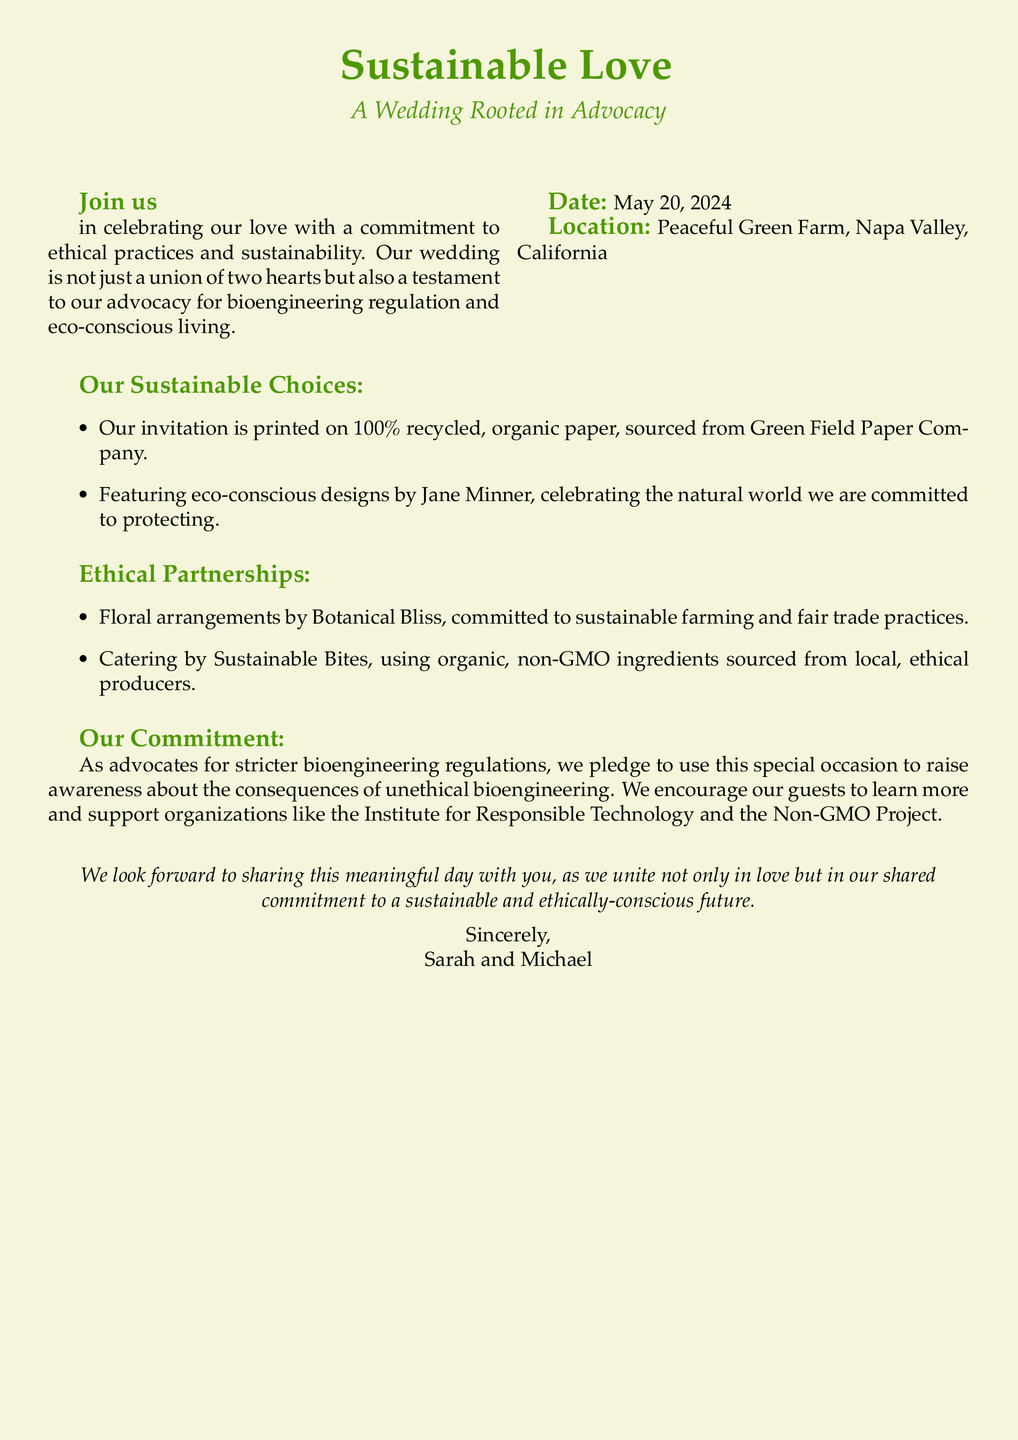What is the title of the wedding celebration? The title is indicated at the top of the document, highlighting the theme of the wedding.
Answer: Sustainable Love What is the wedding date? The document specifies the date of the wedding in a dedicated section.
Answer: May 20, 2024 Where is the wedding location? The location is explicitly mentioned in the invitation details.
Answer: Peaceful Green Farm, Napa Valley, California Who are the couple getting married? The names of the couple are mentioned at the end of the document.
Answer: Sarah and Michael What type of paper is the invitation printed on? The document details the material used for the invitations as a part of their sustainable choices.
Answer: 100% recycled, organic paper Which company designed the eco-conscious invitation? The designer of the invitation is mentioned as part of their sustainable choices in the document.
Answer: Jane Minner What is one of the catering choices mentioned in the document? The document lists the catering service as part of their ethical partnerships.
Answer: Sustainable Bites What do the couple advocate for regarding bioengineering? The document states their commitment and raises awareness about a specific issue.
Answer: Stricter bioengineering regulations What kind of flowers will be used at the wedding? The document discusses the floral arrangements as part of their ethical partnerships.
Answer: Sustainable farming and fair trade practices What message do they want to communicate through their wedding? The last section of the invitation articulates the couple's vision for their special day.
Answer: Sustainable and ethically-conscious future 